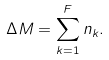Convert formula to latex. <formula><loc_0><loc_0><loc_500><loc_500>\Delta M = \sum _ { k = 1 } ^ { F } n _ { k } .</formula> 